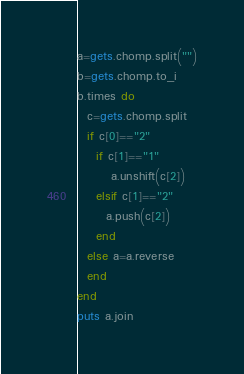<code> <loc_0><loc_0><loc_500><loc_500><_Ruby_>a=gets.chomp.split("")
b=gets.chomp.to_i
b.times do 
  c=gets.chomp.split
  if c[0]=="2"
    if c[1]=="1"
       a.unshift(c[2])
    elsif c[1]=="2"
      a.push(c[2])
    end
  else a=a.reverse
  end
end
puts a.join</code> 